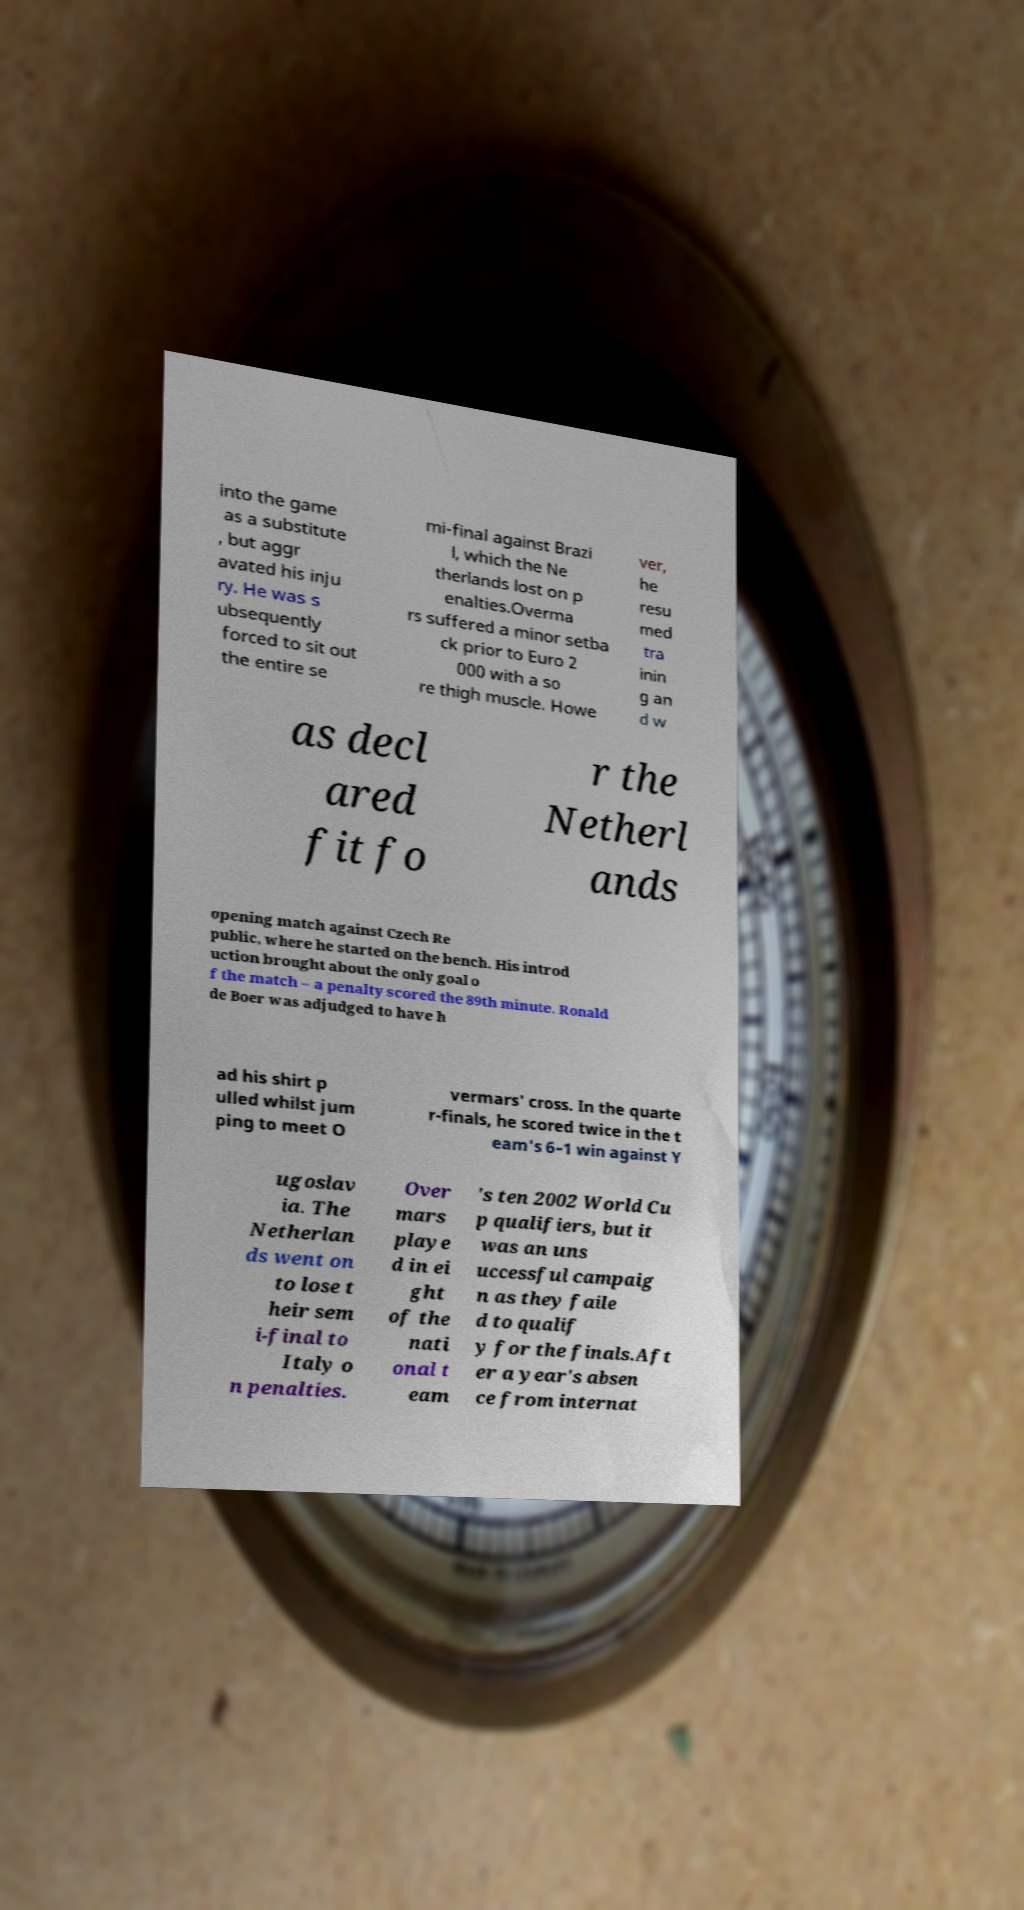Can you accurately transcribe the text from the provided image for me? into the game as a substitute , but aggr avated his inju ry. He was s ubsequently forced to sit out the entire se mi-final against Brazi l, which the Ne therlands lost on p enalties.Overma rs suffered a minor setba ck prior to Euro 2 000 with a so re thigh muscle. Howe ver, he resu med tra inin g an d w as decl ared fit fo r the Netherl ands opening match against Czech Re public, where he started on the bench. His introd uction brought about the only goal o f the match – a penalty scored the 89th minute. Ronald de Boer was adjudged to have h ad his shirt p ulled whilst jum ping to meet O vermars' cross. In the quarte r-finals, he scored twice in the t eam's 6–1 win against Y ugoslav ia. The Netherlan ds went on to lose t heir sem i-final to Italy o n penalties. Over mars playe d in ei ght of the nati onal t eam 's ten 2002 World Cu p qualifiers, but it was an uns uccessful campaig n as they faile d to qualif y for the finals.Aft er a year's absen ce from internat 